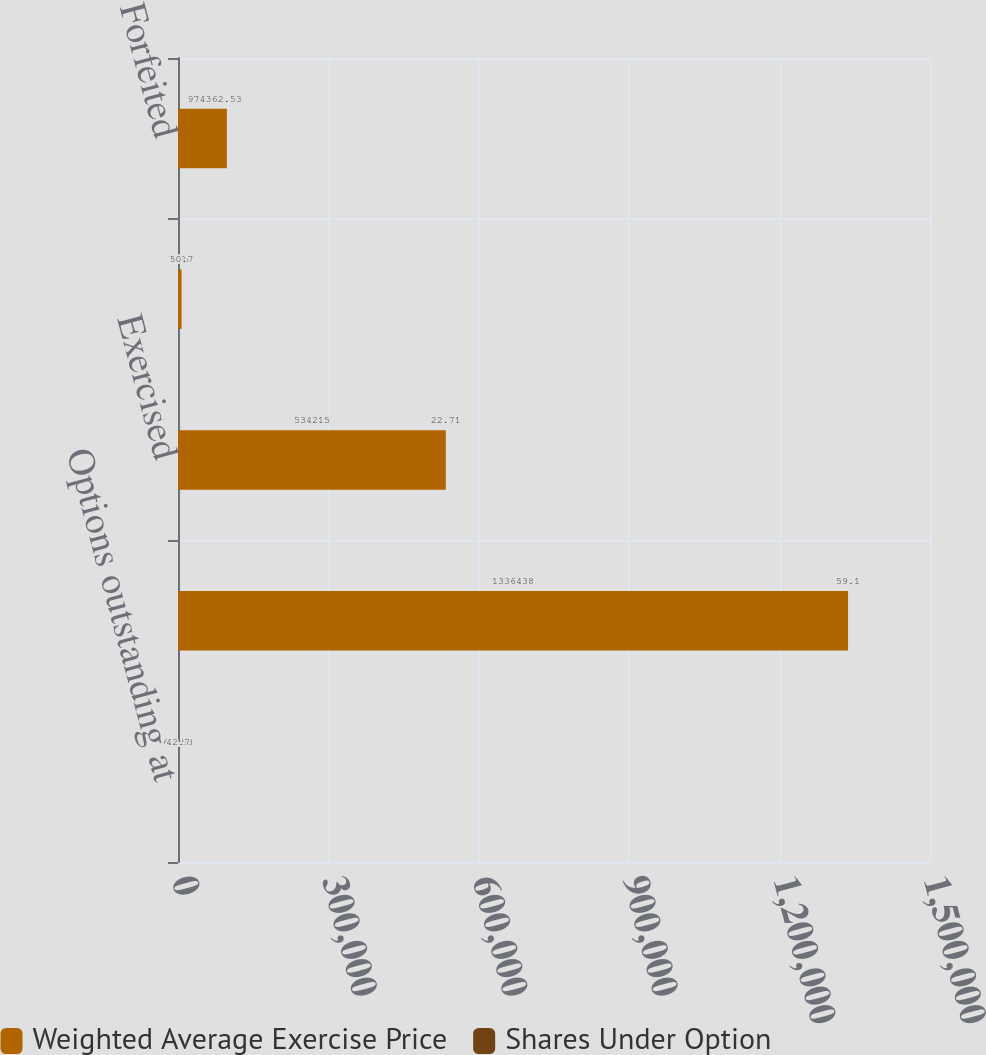<chart> <loc_0><loc_0><loc_500><loc_500><stacked_bar_chart><ecel><fcel>Options outstanding at<fcel>Granted<fcel>Exercised<fcel>Expired<fcel>Forfeited<nl><fcel>Weighted Average Exercise Price<fcel>62.53<fcel>1.33644e+06<fcel>534215<fcel>7098<fcel>97439<nl><fcel>Shares Under Option<fcel>42.7<fcel>59.1<fcel>22.71<fcel>50.7<fcel>62.53<nl></chart> 